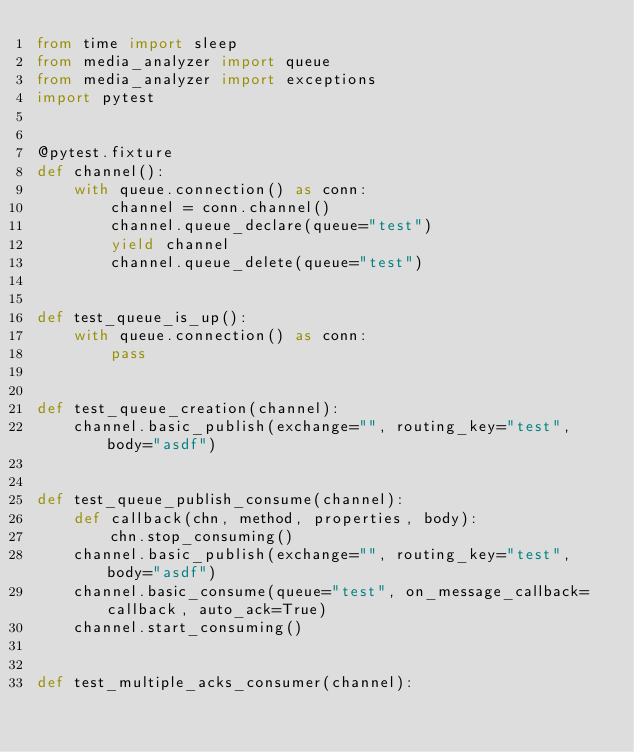<code> <loc_0><loc_0><loc_500><loc_500><_Python_>from time import sleep
from media_analyzer import queue
from media_analyzer import exceptions
import pytest


@pytest.fixture
def channel():
    with queue.connection() as conn:
        channel = conn.channel()
        channel.queue_declare(queue="test")
        yield channel
        channel.queue_delete(queue="test")


def test_queue_is_up():
    with queue.connection() as conn:
        pass
        

def test_queue_creation(channel):
    channel.basic_publish(exchange="", routing_key="test", body="asdf")


def test_queue_publish_consume(channel):
    def callback(chn, method, properties, body):
        chn.stop_consuming()
    channel.basic_publish(exchange="", routing_key="test", body="asdf")
    channel.basic_consume(queue="test", on_message_callback=callback, auto_ack=True)
    channel.start_consuming()


def test_multiple_acks_consumer(channel):</code> 